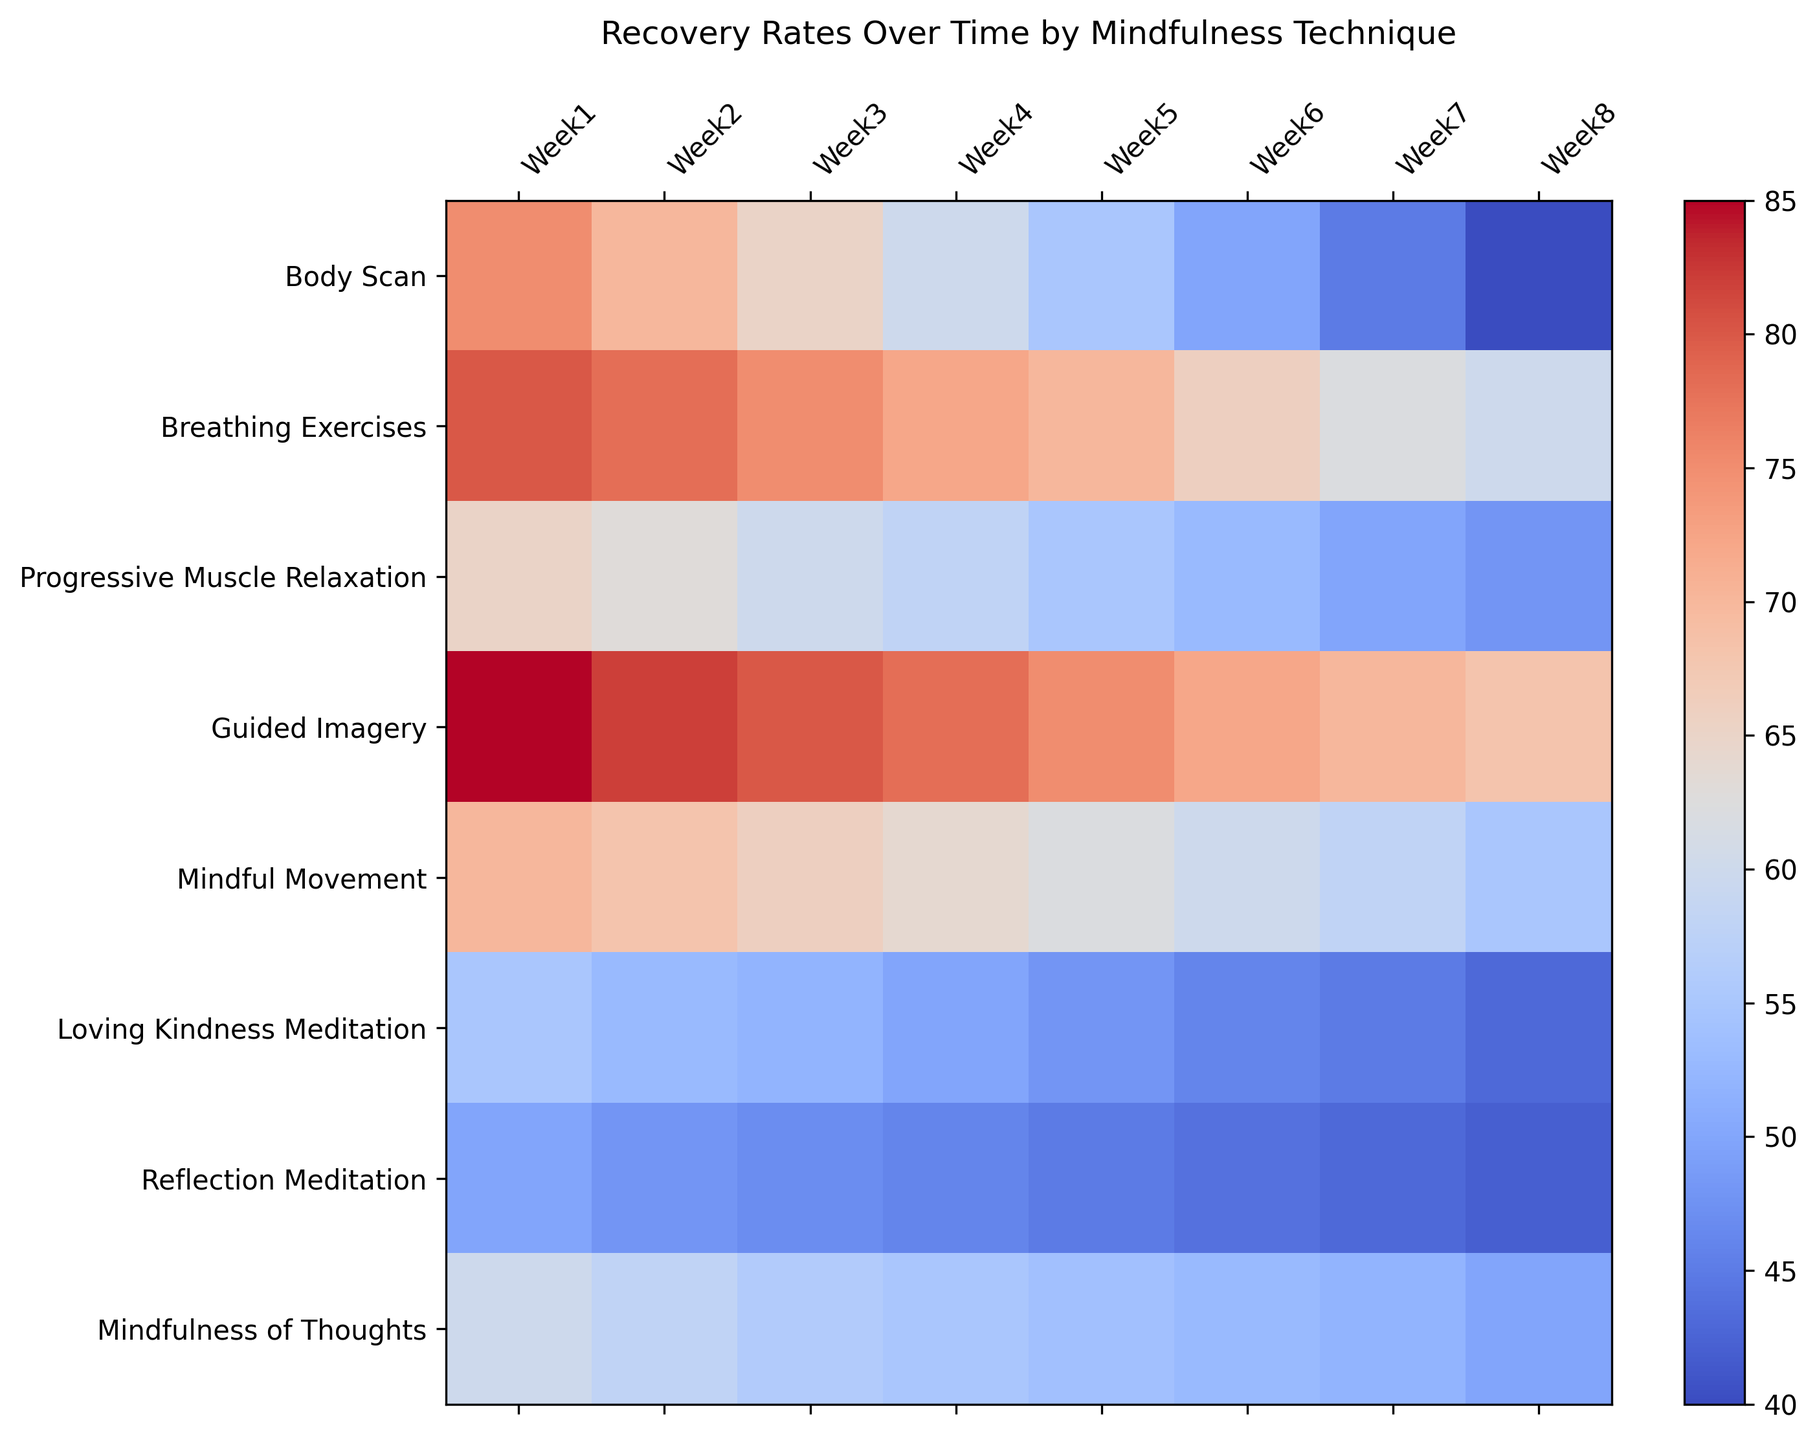How does the recovery rate for Body Scan techniques change over the 8 weeks? The recovery rate for Body Scan starts at 75 in Week 1 and decreases consistently each week to 40 by Week 8.
Answer: Decreases from 75 to 40 Which technique shows the most significant decline in recovery rate over 8 weeks? Calculate the difference between Week 1 and Week 8 for each technique and compare the differences. Guided Imagery shows the most significant decline, dropping from 85 to 68.
Answer: Guided Imagery Which technique has the highest recovery rate in Week 4? Look at the data for Week 4 and identify the highest value. Guided Imagery has the highest recovery rate in Week 4 with 78.
Answer: Guided Imagery Compare the Week 1 and Week 8 recovery rates for Progressive Muscle Relaxation and Reflection Meditation. Which technique has a smaller decline? Subtract the Week 8 value from the Week 1 value for each technique. Progressive Muscle Relaxation: 65 - 48 = 17, Reflection Meditation: 50 - 42 = 8. Reflection Meditation has a smaller decline.
Answer: Reflection Meditation What is the average recovery rate of Breathing Exercises over the entire 8 weeks? Sum up the recovery rates of Breathing Exercises over 8 weeks and divide by 8. (80 + 78 + 75 + 72 + 70 + 66 + 62 + 60) / 8 = 70.4
Answer: 70.4 Which techniques have a recovery rate below 50 by Week 8? Check the values in Week 8 and pick the techniques below 50. Body Scan, Progressive Muscle Relaxation, and Reflection Meditation have recovery rates below 50 by Week 8.
Answer: Body Scan, Progressive Muscle Relaxation, Reflection Meditation Which technique maintains the most stable recovery rate over the 8-week period? Calculate the standard deviation of the recovery rates for each technique over 8 weeks and identify the one with the lowest standard deviation.
Answer: Mindfulness of Thoughts How does the recovery rate for Mindful Movement compare to that of Loving Kindness Meditation by Week 6? Compare the values of Mindful Movement and Loving Kindness Meditation in Week 6. Mindful Movement: 60, Loving Kindness Meditation: 46. Mindful Movement has a higher recovery rate.
Answer: Mindful Movement is higher What is the sum of the recovery rates for Guided Imagery in the first four weeks? Sum the recovery rates for Guided Imagery in Week 1 to Week 4. 85 + 82 + 80 + 78 = 325
Answer: 325 